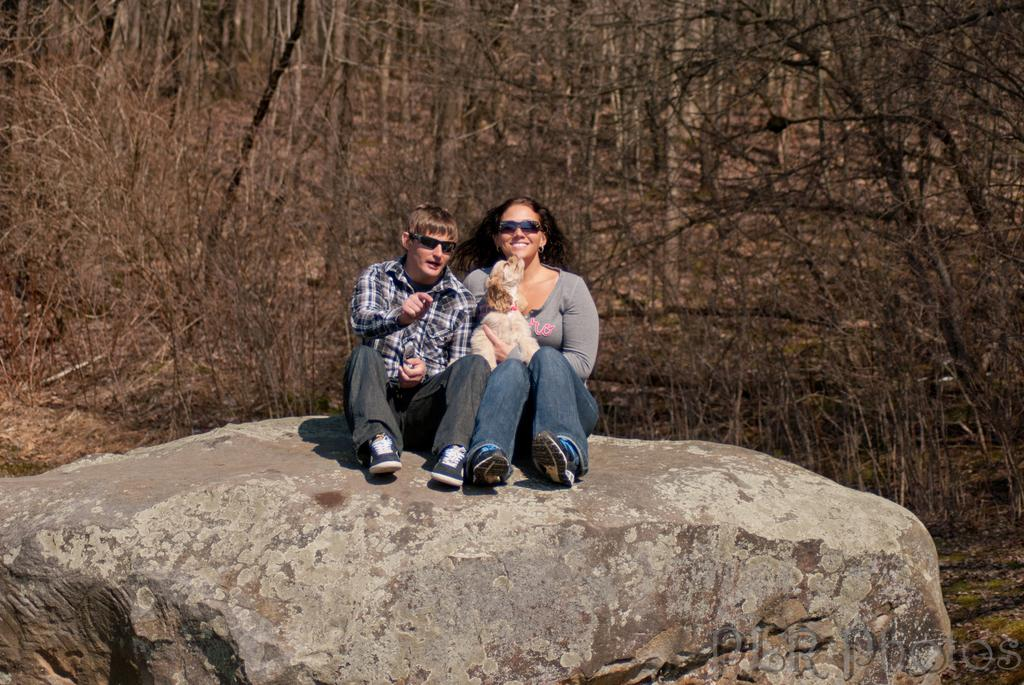How many people are sitting on the rock in the image? There are two persons sitting on a rock in the image. What is the dog doing in the image? The dog is sitting on a woman in the image. When was the image taken? The image was taken during the day. What can be seen in the background of the image? There are trees in the background of the image. What type of key is the man holding in the image? There is no key present in the image; it features two persons sitting on a rock and a dog sitting on a woman. 